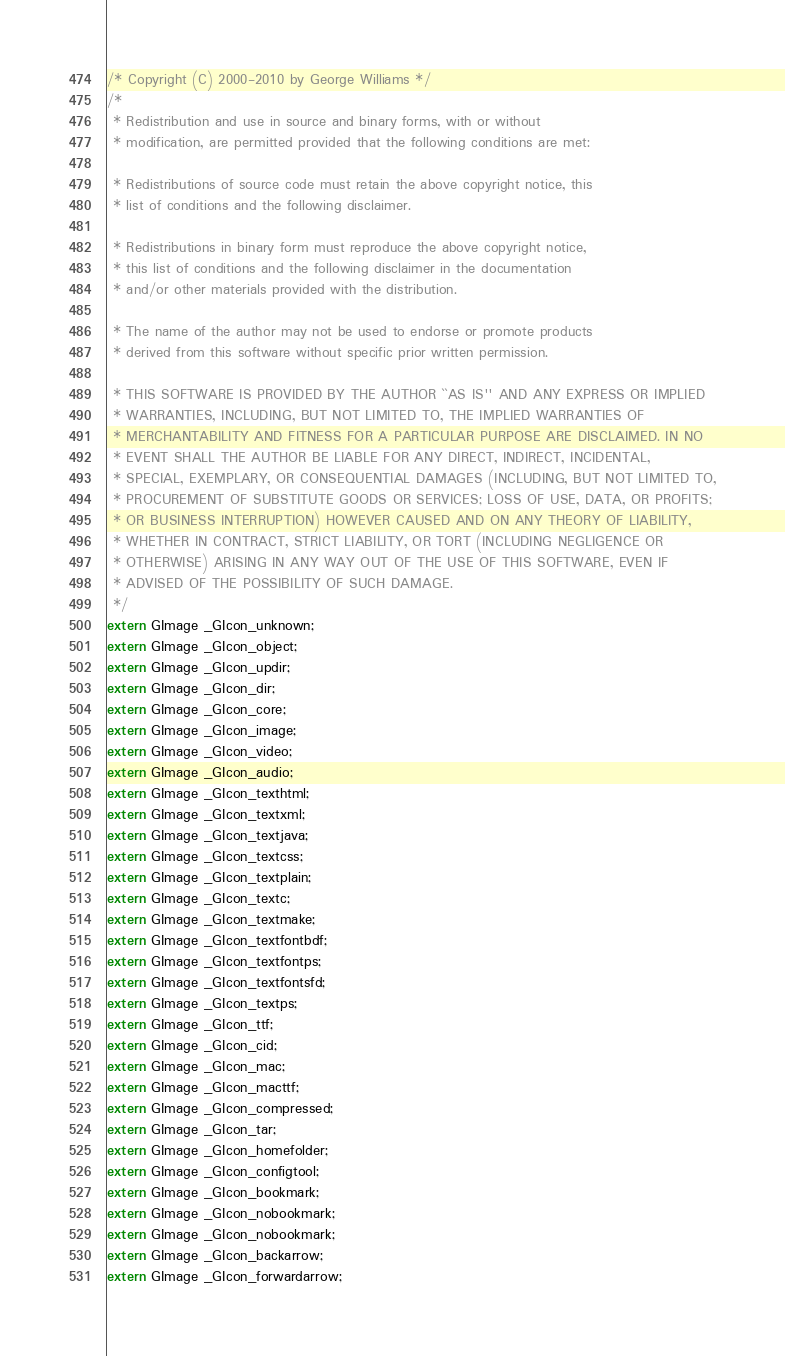Convert code to text. <code><loc_0><loc_0><loc_500><loc_500><_C_>/* Copyright (C) 2000-2010 by George Williams */
/*
 * Redistribution and use in source and binary forms, with or without
 * modification, are permitted provided that the following conditions are met:

 * Redistributions of source code must retain the above copyright notice, this
 * list of conditions and the following disclaimer.

 * Redistributions in binary form must reproduce the above copyright notice,
 * this list of conditions and the following disclaimer in the documentation
 * and/or other materials provided with the distribution.

 * The name of the author may not be used to endorse or promote products
 * derived from this software without specific prior written permission.

 * THIS SOFTWARE IS PROVIDED BY THE AUTHOR ``AS IS'' AND ANY EXPRESS OR IMPLIED
 * WARRANTIES, INCLUDING, BUT NOT LIMITED TO, THE IMPLIED WARRANTIES OF
 * MERCHANTABILITY AND FITNESS FOR A PARTICULAR PURPOSE ARE DISCLAIMED. IN NO
 * EVENT SHALL THE AUTHOR BE LIABLE FOR ANY DIRECT, INDIRECT, INCIDENTAL,
 * SPECIAL, EXEMPLARY, OR CONSEQUENTIAL DAMAGES (INCLUDING, BUT NOT LIMITED TO,
 * PROCUREMENT OF SUBSTITUTE GOODS OR SERVICES; LOSS OF USE, DATA, OR PROFITS;
 * OR BUSINESS INTERRUPTION) HOWEVER CAUSED AND ON ANY THEORY OF LIABILITY,
 * WHETHER IN CONTRACT, STRICT LIABILITY, OR TORT (INCLUDING NEGLIGENCE OR
 * OTHERWISE) ARISING IN ANY WAY OUT OF THE USE OF THIS SOFTWARE, EVEN IF
 * ADVISED OF THE POSSIBILITY OF SUCH DAMAGE.
 */
extern GImage _GIcon_unknown;
extern GImage _GIcon_object;
extern GImage _GIcon_updir;
extern GImage _GIcon_dir;
extern GImage _GIcon_core;
extern GImage _GIcon_image;
extern GImage _GIcon_video;
extern GImage _GIcon_audio;
extern GImage _GIcon_texthtml;
extern GImage _GIcon_textxml;
extern GImage _GIcon_textjava;
extern GImage _GIcon_textcss;
extern GImage _GIcon_textplain;
extern GImage _GIcon_textc;
extern GImage _GIcon_textmake;
extern GImage _GIcon_textfontbdf;
extern GImage _GIcon_textfontps;
extern GImage _GIcon_textfontsfd;
extern GImage _GIcon_textps;
extern GImage _GIcon_ttf;
extern GImage _GIcon_cid;
extern GImage _GIcon_mac;
extern GImage _GIcon_macttf;
extern GImage _GIcon_compressed;
extern GImage _GIcon_tar;
extern GImage _GIcon_homefolder;
extern GImage _GIcon_configtool;
extern GImage _GIcon_bookmark;
extern GImage _GIcon_nobookmark;
extern GImage _GIcon_nobookmark;
extern GImage _GIcon_backarrow;
extern GImage _GIcon_forwardarrow;
</code> 